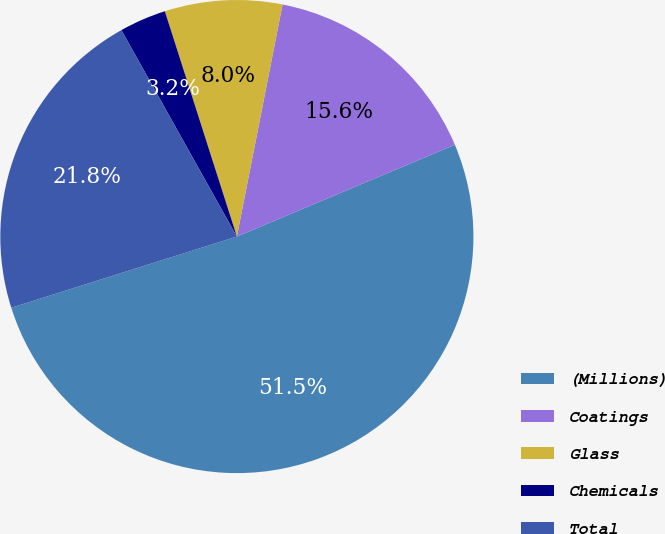Convert chart. <chart><loc_0><loc_0><loc_500><loc_500><pie_chart><fcel>(Millions)<fcel>Coatings<fcel>Glass<fcel>Chemicals<fcel>Total<nl><fcel>51.48%<fcel>15.56%<fcel>8.02%<fcel>3.19%<fcel>21.75%<nl></chart> 